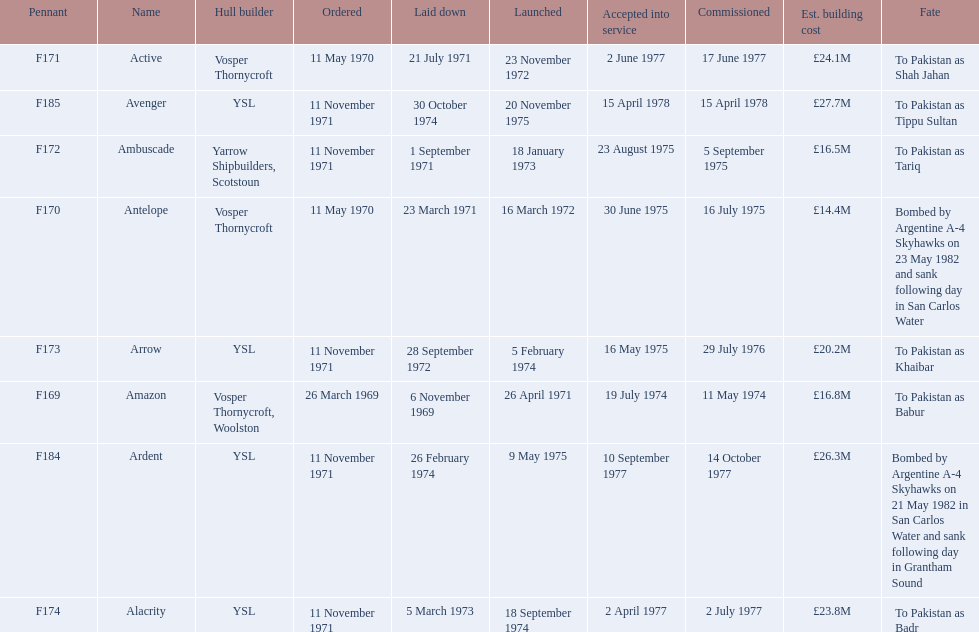What were the estimated building costs of the frigates? £16.8M, £14.4M, £16.5M, £20.2M, £24.1M, £23.8M, £26.3M, £27.7M. Which of these is the largest? £27.7M. What ship name does that correspond to? Avenger. 